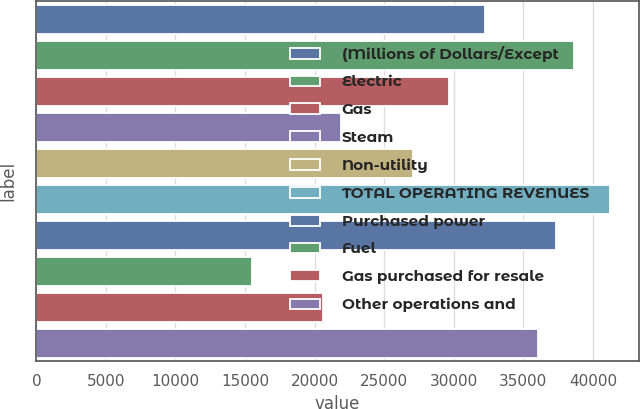Convert chart to OTSL. <chart><loc_0><loc_0><loc_500><loc_500><bar_chart><fcel>(Millions of Dollars/Except<fcel>Electric<fcel>Gas<fcel>Steam<fcel>Non-utility<fcel>TOTAL OPERATING REVENUES<fcel>Purchased power<fcel>Fuel<fcel>Gas purchased for resale<fcel>Other operations and<nl><fcel>32211.4<fcel>38653.2<fcel>29634.7<fcel>21904.5<fcel>27058<fcel>41229.9<fcel>37364.8<fcel>15462.7<fcel>20616.2<fcel>36076.5<nl></chart> 